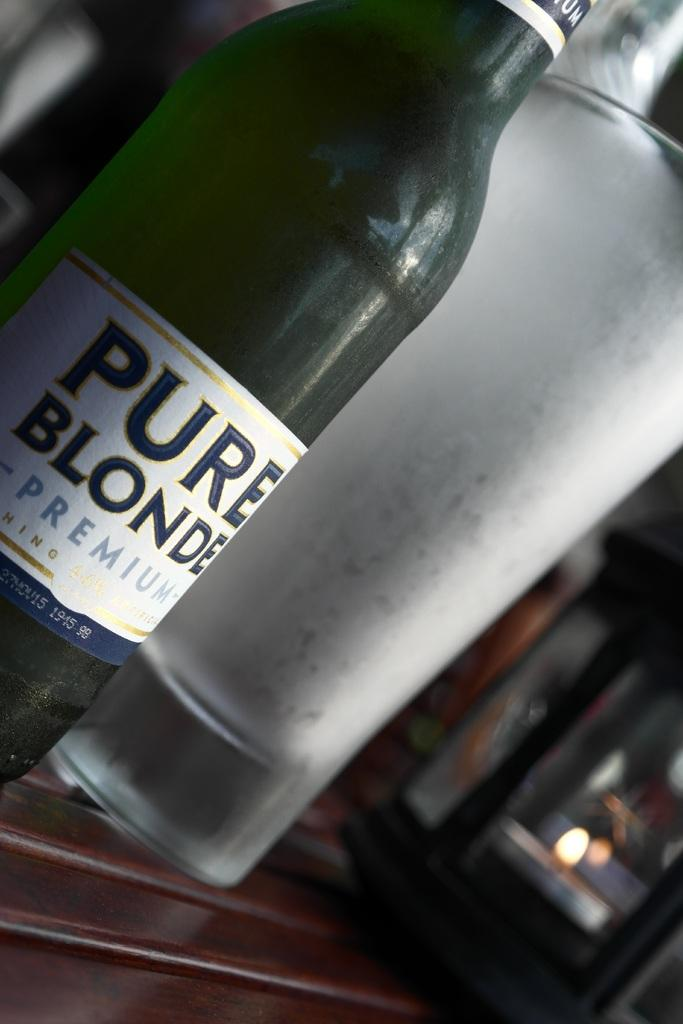Provide a one-sentence caption for the provided image. Pure Blonde Premium bottle next to a tall glass cup. 